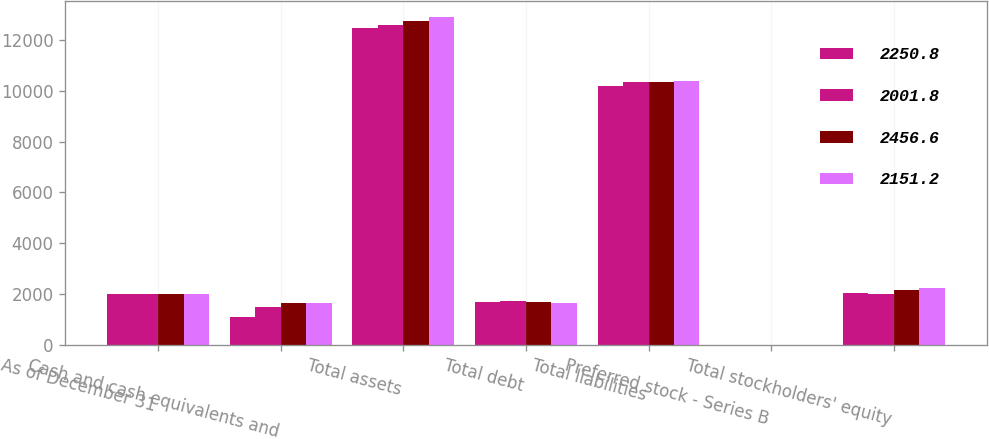Convert chart. <chart><loc_0><loc_0><loc_500><loc_500><stacked_bar_chart><ecel><fcel>As of December 31<fcel>Cash and cash equivalents and<fcel>Total assets<fcel>Total debt<fcel>Total liabilities<fcel>Preferred stock - Series B<fcel>Total stockholders' equity<nl><fcel>2250.8<fcel>2016<fcel>1100.6<fcel>12485.2<fcel>1690.3<fcel>10175.7<fcel>0<fcel>2056.7<nl><fcel>2001.8<fcel>2015<fcel>1509.7<fcel>12585.1<fcel>1745.1<fcel>10331.4<fcel>0<fcel>2001.8<nl><fcel>2456.6<fcel>2014<fcel>1667.2<fcel>12736.6<fcel>1705.5<fcel>10328<fcel>0<fcel>2151.2<nl><fcel>2151.2<fcel>2013<fcel>1642.1<fcel>12896.9<fcel>1640.8<fcel>10397<fcel>0<fcel>2250.8<nl></chart> 